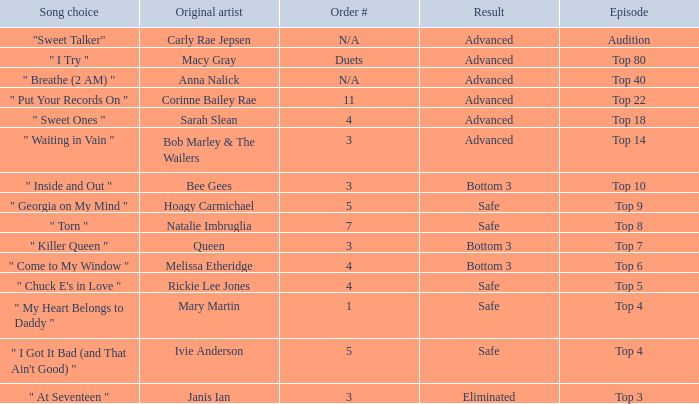What's the total number of songs originally performed by Anna Nalick? 1.0. 